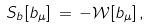Convert formula to latex. <formula><loc_0><loc_0><loc_500><loc_500>S _ { b } [ b _ { \mu } ] \, = \, - { \mathcal { W } } [ b _ { \mu } ] \, ,</formula> 